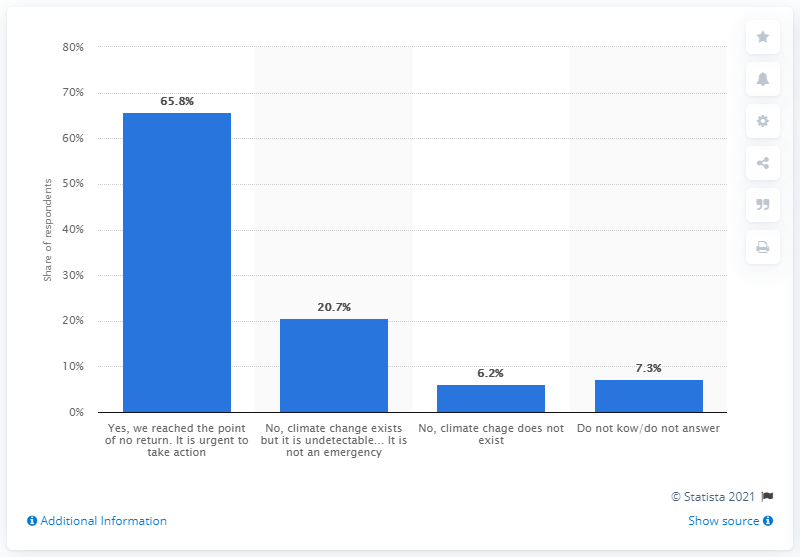Specify some key components in this picture. According to the survey, 20.7% of Italians did not believe that climate change was a real emergency. 